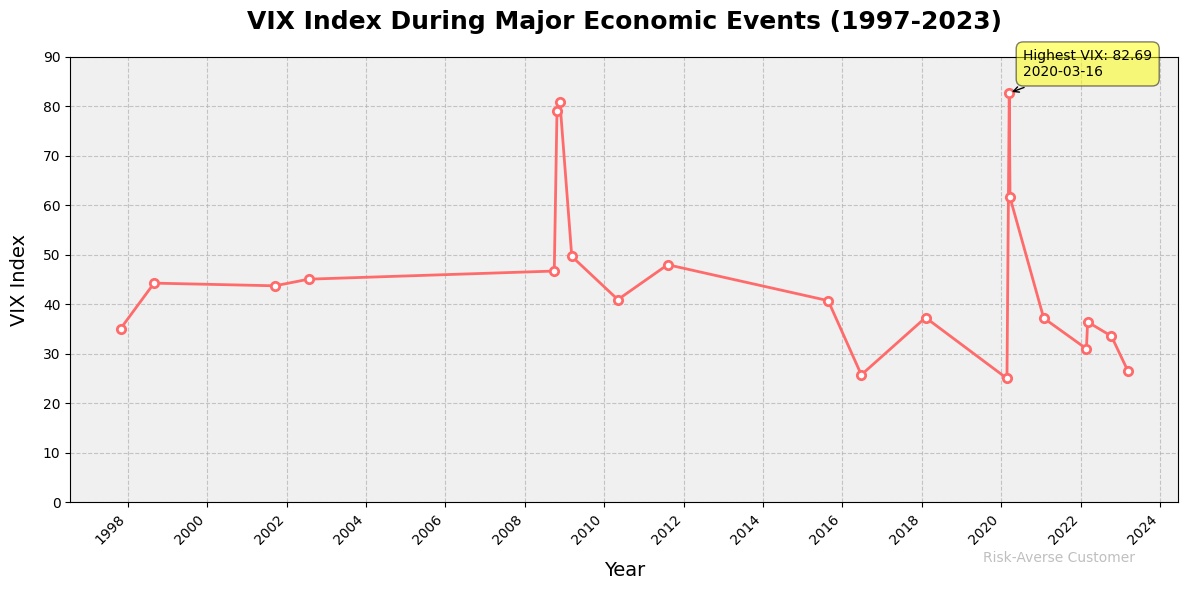Which year had the highest VIX value? The annotation on the plot indicates that the highest VIX value was 82.69, which occurred on 2020-03-16.
Answer: 2020 How did the VIX value change from 1997-10-27 to 2008-10-24? On 1997-10-27, the VIX was 35.09. By 2008-10-24, it increased significantly to 79.13. The change is 79.13 - 35.09 = 44.04.
Answer: Increased by 44.04 Which dates in the figure show VIX values above 80? The plot shows two dates with VIX values above 80: 2008-11-20 with a VIX of 80.86 and 2020-03-16 with a VIX of 82.69.
Answer: 2008-11-20 and 2020-03-16 Compare the VIX value on 2008-10-24 and 2022-03-07. Which one is higher? On 2008-10-24, the VIX value is 79.13. On 2022-03-07, it is 36.45. 79.13 is higher than 36.45.
Answer: 2008-10-24 What was the VIX value during the 2008 financial crisis peak? The plot shows a significant peak during the 2008 financial crisis, with the highest VIX on 2008-11-20 at 80.86.
Answer: 80.86 How many times did the VIX exceed 40 between 1997 and 2023? By inspecting the plot, the VIX exceeded 40 on these dates: 1997-10-27, 1998-08-31, 2001-09-17, 2002-07-24, 2008-09-29, 2008-10-24, 2008-11-20, 2009-03-09, 2010-05-07, 2011-08-08, 2015-08-24, and 2020-03-16. That's 12 times in total.
Answer: 12 What is the average VIX value during the economic events of 2022, as shown in the figure? The VIX values for 2022 are 31.02 (2022-02-24), 36.45 (2022-03-07), and 33.57 (2022-10-12). The average is (31.02 + 36.45 + 33.57) / 3 = 101.04 / 3 = 33.68.
Answer: 33.68 Did the VIX value ever reach its minimum (0-10) in the given period? No. The lowest value represented in the plot does not fall within the 0-10 range. The minimum values are all above 10.
Answer: No 